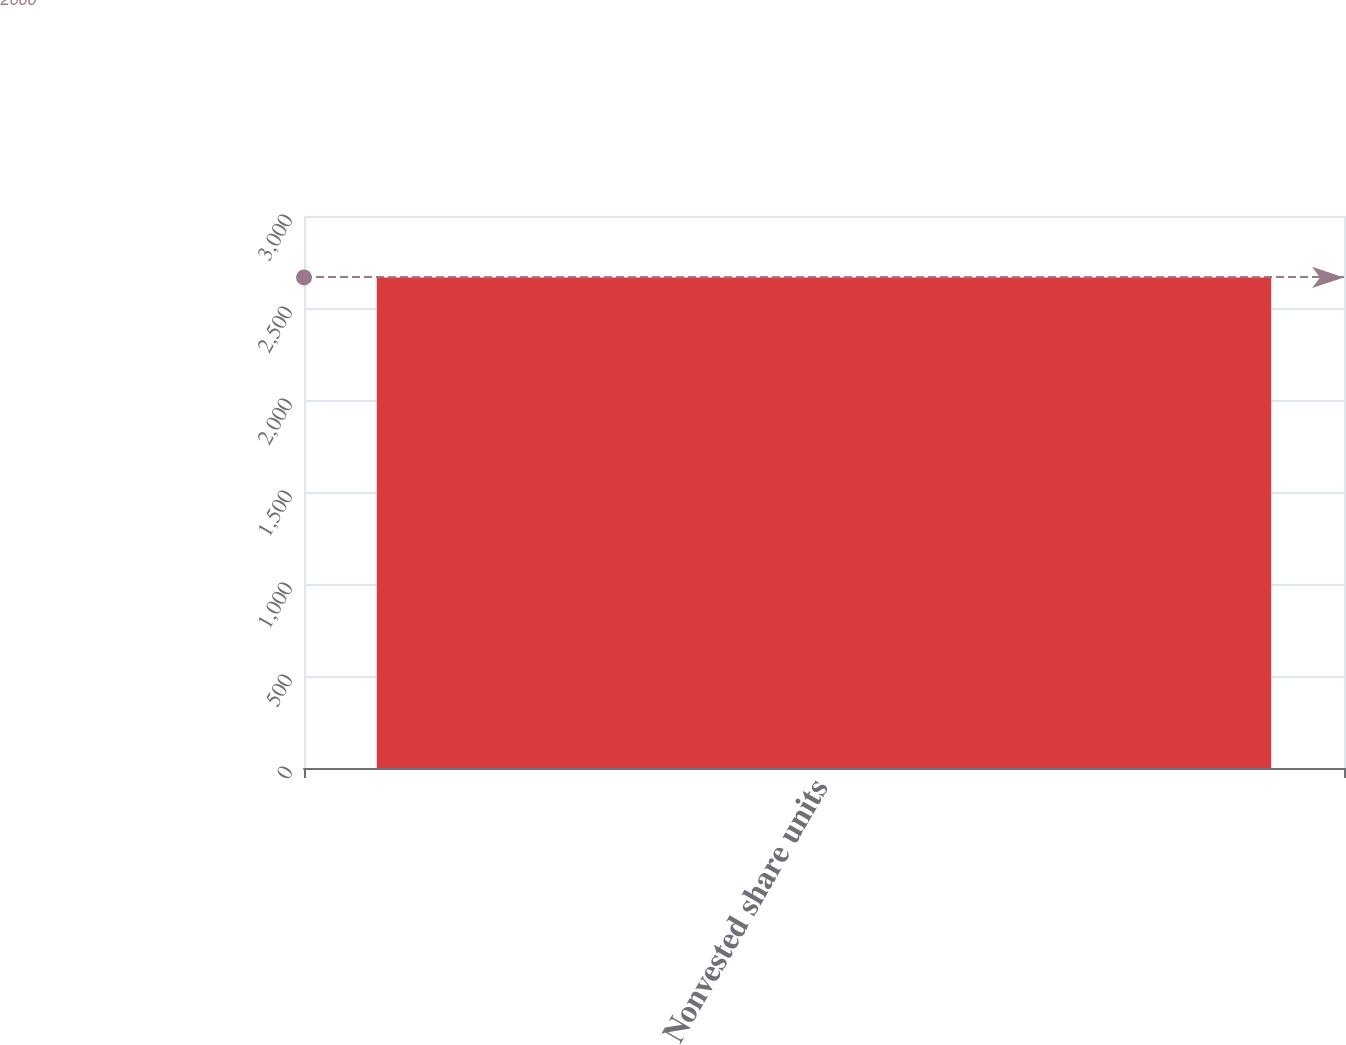<chart> <loc_0><loc_0><loc_500><loc_500><bar_chart><fcel>Nonvested share units<nl><fcel>2666<nl></chart> 